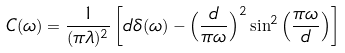<formula> <loc_0><loc_0><loc_500><loc_500>C ( \omega ) = \frac { 1 } { ( \pi \lambda ) ^ { 2 } } \left [ d \delta ( \omega ) - \left ( \frac { d } { \pi \omega } \right ) ^ { 2 } \sin ^ { 2 } \left ( \frac { \pi \omega } { d } \right ) \right ]</formula> 